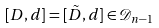Convert formula to latex. <formula><loc_0><loc_0><loc_500><loc_500>[ D , d ] = [ \tilde { D } , d ] \in \mathcal { D } _ { n - 1 }</formula> 